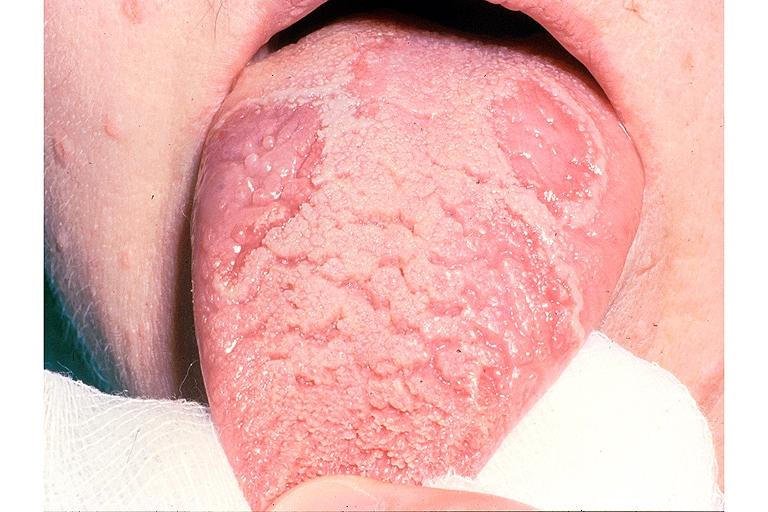s neoplasm gland present?
Answer the question using a single word or phrase. No 